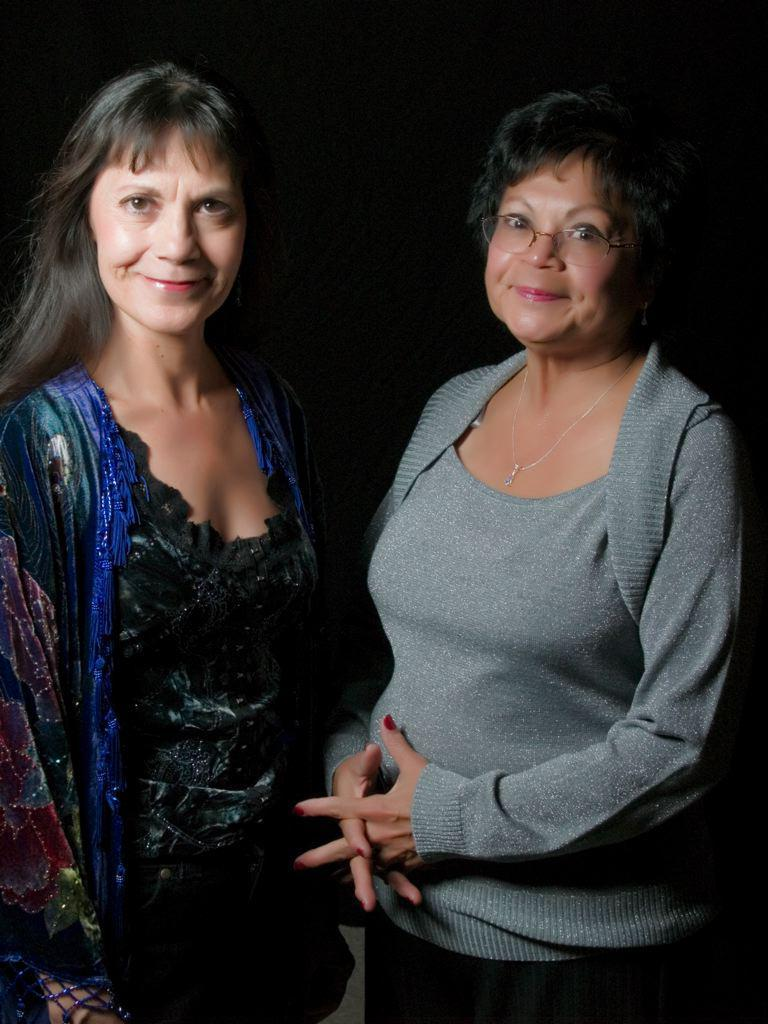How many people are in the foreground of the image? There are two women in the foreground of the image. What are the women doing in the image? The women are standing and posing for the camera. What expressions do the women have on their faces? The women have smiles on their faces. What can be seen in the background of the image? The background of the image is dark. What type of coat is the woman on the left wearing in the image? There is no coat visible in the image; the women are not wearing any outerwear. What is the woman on the right writing in her notebook in the image? There is no notebook present in the image; the women are not holding any writing materials. 